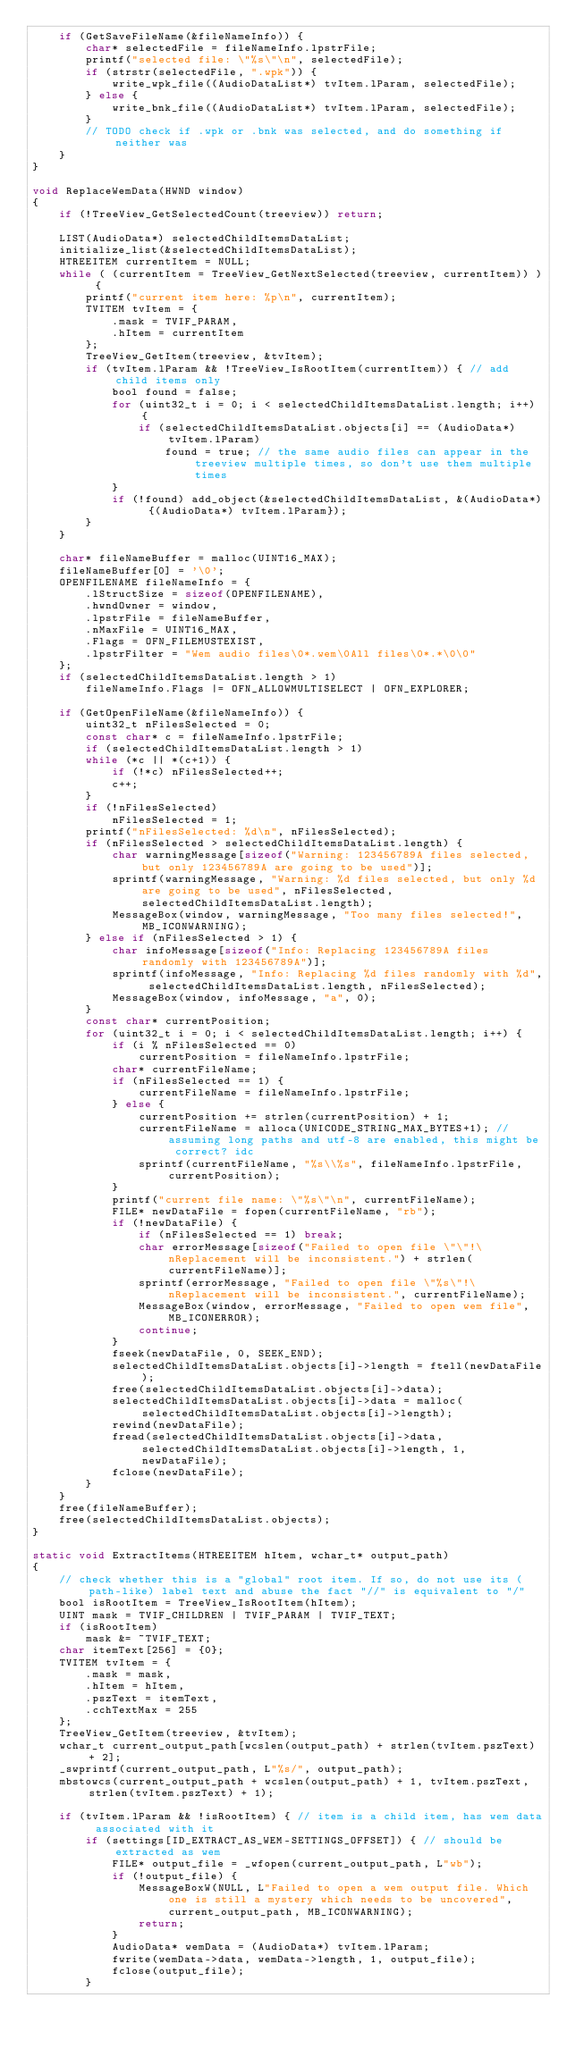<code> <loc_0><loc_0><loc_500><loc_500><_C_>    if (GetSaveFileName(&fileNameInfo)) {
        char* selectedFile = fileNameInfo.lpstrFile;
        printf("selected file: \"%s\"\n", selectedFile);
        if (strstr(selectedFile, ".wpk")) {
            write_wpk_file((AudioDataList*) tvItem.lParam, selectedFile);
        } else {
            write_bnk_file((AudioDataList*) tvItem.lParam, selectedFile);
        }
        // TODO check if .wpk or .bnk was selected, and do something if neither was
    }
}

void ReplaceWemData(HWND window)
{
    if (!TreeView_GetSelectedCount(treeview)) return;

    LIST(AudioData*) selectedChildItemsDataList;
    initialize_list(&selectedChildItemsDataList);
    HTREEITEM currentItem = NULL;
    while ( (currentItem = TreeView_GetNextSelected(treeview, currentItem)) ) {
        printf("current item here: %p\n", currentItem);
        TVITEM tvItem = {
            .mask = TVIF_PARAM,
            .hItem = currentItem
        };
        TreeView_GetItem(treeview, &tvItem);
        if (tvItem.lParam && !TreeView_IsRootItem(currentItem)) { // add child items only
            bool found = false;
            for (uint32_t i = 0; i < selectedChildItemsDataList.length; i++) {
                if (selectedChildItemsDataList.objects[i] == (AudioData*) tvItem.lParam)
                    found = true; // the same audio files can appear in the treeview multiple times, so don't use them multiple times
            }
            if (!found) add_object(&selectedChildItemsDataList, &(AudioData*) {(AudioData*) tvItem.lParam});
        }
    }

    char* fileNameBuffer = malloc(UINT16_MAX);
    fileNameBuffer[0] = '\0';
    OPENFILENAME fileNameInfo = {
        .lStructSize = sizeof(OPENFILENAME),
        .hwndOwner = window,
        .lpstrFile = fileNameBuffer,
        .nMaxFile = UINT16_MAX,
        .Flags = OFN_FILEMUSTEXIST,
        .lpstrFilter = "Wem audio files\0*.wem\0All files\0*.*\0\0"
    };
    if (selectedChildItemsDataList.length > 1)
        fileNameInfo.Flags |= OFN_ALLOWMULTISELECT | OFN_EXPLORER;

    if (GetOpenFileName(&fileNameInfo)) {
        uint32_t nFilesSelected = 0;
        const char* c = fileNameInfo.lpstrFile;
        if (selectedChildItemsDataList.length > 1)
        while (*c || *(c+1)) {
            if (!*c) nFilesSelected++;
            c++;
        }
        if (!nFilesSelected)
            nFilesSelected = 1;
        printf("nFilesSelected: %d\n", nFilesSelected);
        if (nFilesSelected > selectedChildItemsDataList.length) {
            char warningMessage[sizeof("Warning: 123456789A files selected, but only 123456789A are going to be used")];
            sprintf(warningMessage, "Warning: %d files selected, but only %d are going to be used", nFilesSelected, selectedChildItemsDataList.length);
            MessageBox(window, warningMessage, "Too many files selected!", MB_ICONWARNING);
        } else if (nFilesSelected > 1) {
            char infoMessage[sizeof("Info: Replacing 123456789A files randomly with 123456789A")];
            sprintf(infoMessage, "Info: Replacing %d files randomly with %d", selectedChildItemsDataList.length, nFilesSelected);
            MessageBox(window, infoMessage, "a", 0);
        }
        const char* currentPosition;
        for (uint32_t i = 0; i < selectedChildItemsDataList.length; i++) {
            if (i % nFilesSelected == 0)
                currentPosition = fileNameInfo.lpstrFile;
            char* currentFileName;
            if (nFilesSelected == 1) {
                currentFileName = fileNameInfo.lpstrFile;
            } else {
                currentPosition += strlen(currentPosition) + 1;
                currentFileName = alloca(UNICODE_STRING_MAX_BYTES+1); // assuming long paths and utf-8 are enabled, this might be correct? idc
                sprintf(currentFileName, "%s\\%s", fileNameInfo.lpstrFile, currentPosition);
            }
            printf("current file name: \"%s\"\n", currentFileName);
            FILE* newDataFile = fopen(currentFileName, "rb");
            if (!newDataFile) {
                if (nFilesSelected == 1) break;
                char errorMessage[sizeof("Failed to open file \"\"!\nReplacement will be inconsistent.") + strlen(currentFileName)];
                sprintf(errorMessage, "Failed to open file \"%s\"!\nReplacement will be inconsistent.", currentFileName);
                MessageBox(window, errorMessage, "Failed to open wem file", MB_ICONERROR);
                continue;
            }
            fseek(newDataFile, 0, SEEK_END);
            selectedChildItemsDataList.objects[i]->length = ftell(newDataFile);
            free(selectedChildItemsDataList.objects[i]->data);
            selectedChildItemsDataList.objects[i]->data = malloc(selectedChildItemsDataList.objects[i]->length);
            rewind(newDataFile);
            fread(selectedChildItemsDataList.objects[i]->data, selectedChildItemsDataList.objects[i]->length, 1, newDataFile);
            fclose(newDataFile);
        }
    }
    free(fileNameBuffer);
    free(selectedChildItemsDataList.objects);
}

static void ExtractItems(HTREEITEM hItem, wchar_t* output_path)
{
    // check whether this is a "global" root item. If so, do not use its (path-like) label text and abuse the fact "//" is equivalent to "/"
    bool isRootItem = TreeView_IsRootItem(hItem);
    UINT mask = TVIF_CHILDREN | TVIF_PARAM | TVIF_TEXT;
    if (isRootItem)
        mask &= ~TVIF_TEXT;
    char itemText[256] = {0};
    TVITEM tvItem = {
        .mask = mask,
        .hItem = hItem,
        .pszText = itemText,
        .cchTextMax = 255
    };
    TreeView_GetItem(treeview, &tvItem);
    wchar_t current_output_path[wcslen(output_path) + strlen(tvItem.pszText) + 2];
    _swprintf(current_output_path, L"%s/", output_path);
    mbstowcs(current_output_path + wcslen(output_path) + 1, tvItem.pszText, strlen(tvItem.pszText) + 1);

    if (tvItem.lParam && !isRootItem) { // item is a child item, has wem data associated with it
        if (settings[ID_EXTRACT_AS_WEM-SETTINGS_OFFSET]) { // should be extracted as wem
            FILE* output_file = _wfopen(current_output_path, L"wb");
            if (!output_file) {
                MessageBoxW(NULL, L"Failed to open a wem output file. Which one is still a mystery which needs to be uncovered", current_output_path, MB_ICONWARNING);
                return;
            }
            AudioData* wemData = (AudioData*) tvItem.lParam;
            fwrite(wemData->data, wemData->length, 1, output_file);
            fclose(output_file);
        }
</code> 